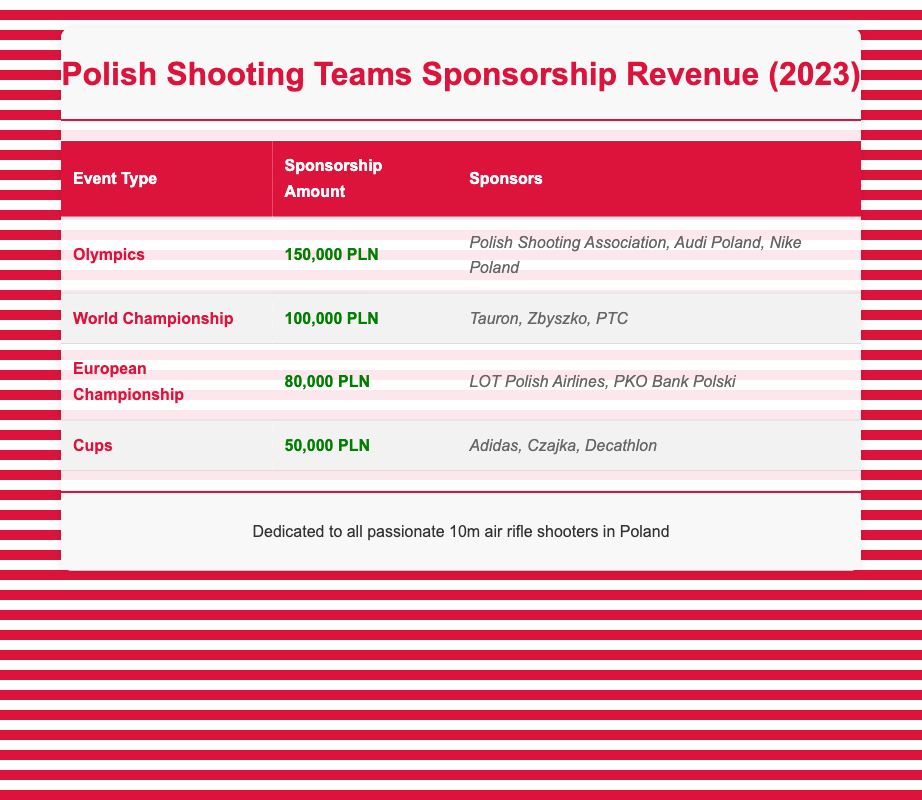What is the total sponsorship amount for Polish shooting teams in 2023? To find the total sponsorship amount, we add the amounts from all events: 150000 + 100000 + 80000 + 50000 = 380000.
Answer: 380000 PLN How many sponsors are associated with the Olympic event? The Olympic event has three sponsors listed: Polish Shooting Association, Audi Poland, and Nike Poland.
Answer: 3 Which event has the lowest sponsorship amount? The Cups event has the lowest sponsorship amount of 50000 PLN when compared to others: Olympics (150000), World Championship (100000), and European Championship (80000).
Answer: Cups Is there a sponsor that appears in more than one event type? Based on the table, all sponsors are unique to their respective events and do not appear in more than one event.
Answer: No What is the average sponsorship amount for the events listed? To calculate the average, sum the amounts: (150000 + 100000 + 80000 + 50000 = 380000) and divide by the number of events (4): 380000 / 4 = 95000.
Answer: 95000 PLN How much more sponsorship money did the Olympics receive compared to the Cups? The difference in sponsorship between the Olympics (150000) and the Cups (50000) is calculated as follows: 150000 - 50000 = 100000.
Answer: 100000 PLN Which sponsors support the European Championship? The European Championship is supported by LOT Polish Airlines and PKO Bank Polski, according to the table.
Answer: LOT Polish Airlines, PKO Bank Polski What is the total sponsorship amount from the top two events? To find the total from the top two events (Olympics and World Championship), we add their amounts: 150000 + 100000 = 250000.
Answer: 250000 PLN 